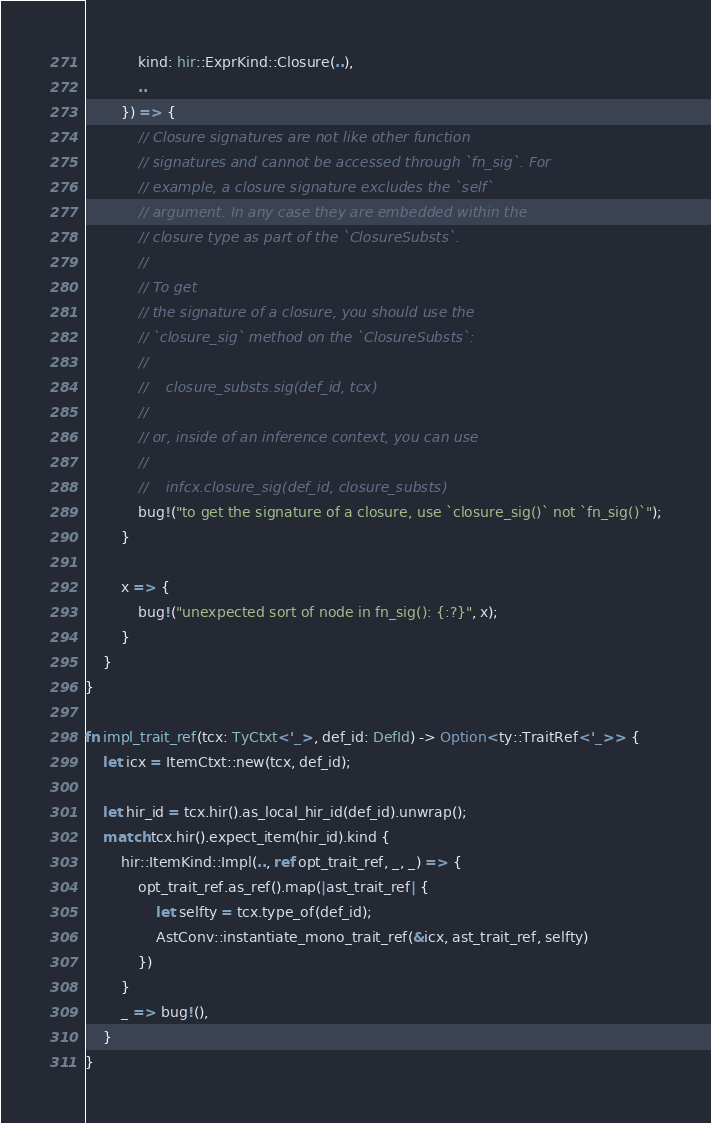Convert code to text. <code><loc_0><loc_0><loc_500><loc_500><_Rust_>            kind: hir::ExprKind::Closure(..),
            ..
        }) => {
            // Closure signatures are not like other function
            // signatures and cannot be accessed through `fn_sig`. For
            // example, a closure signature excludes the `self`
            // argument. In any case they are embedded within the
            // closure type as part of the `ClosureSubsts`.
            //
            // To get
            // the signature of a closure, you should use the
            // `closure_sig` method on the `ClosureSubsts`:
            //
            //    closure_substs.sig(def_id, tcx)
            //
            // or, inside of an inference context, you can use
            //
            //    infcx.closure_sig(def_id, closure_substs)
            bug!("to get the signature of a closure, use `closure_sig()` not `fn_sig()`");
        }

        x => {
            bug!("unexpected sort of node in fn_sig(): {:?}", x);
        }
    }
}

fn impl_trait_ref(tcx: TyCtxt<'_>, def_id: DefId) -> Option<ty::TraitRef<'_>> {
    let icx = ItemCtxt::new(tcx, def_id);

    let hir_id = tcx.hir().as_local_hir_id(def_id).unwrap();
    match tcx.hir().expect_item(hir_id).kind {
        hir::ItemKind::Impl(.., ref opt_trait_ref, _, _) => {
            opt_trait_ref.as_ref().map(|ast_trait_ref| {
                let selfty = tcx.type_of(def_id);
                AstConv::instantiate_mono_trait_ref(&icx, ast_trait_ref, selfty)
            })
        }
        _ => bug!(),
    }
}
</code> 